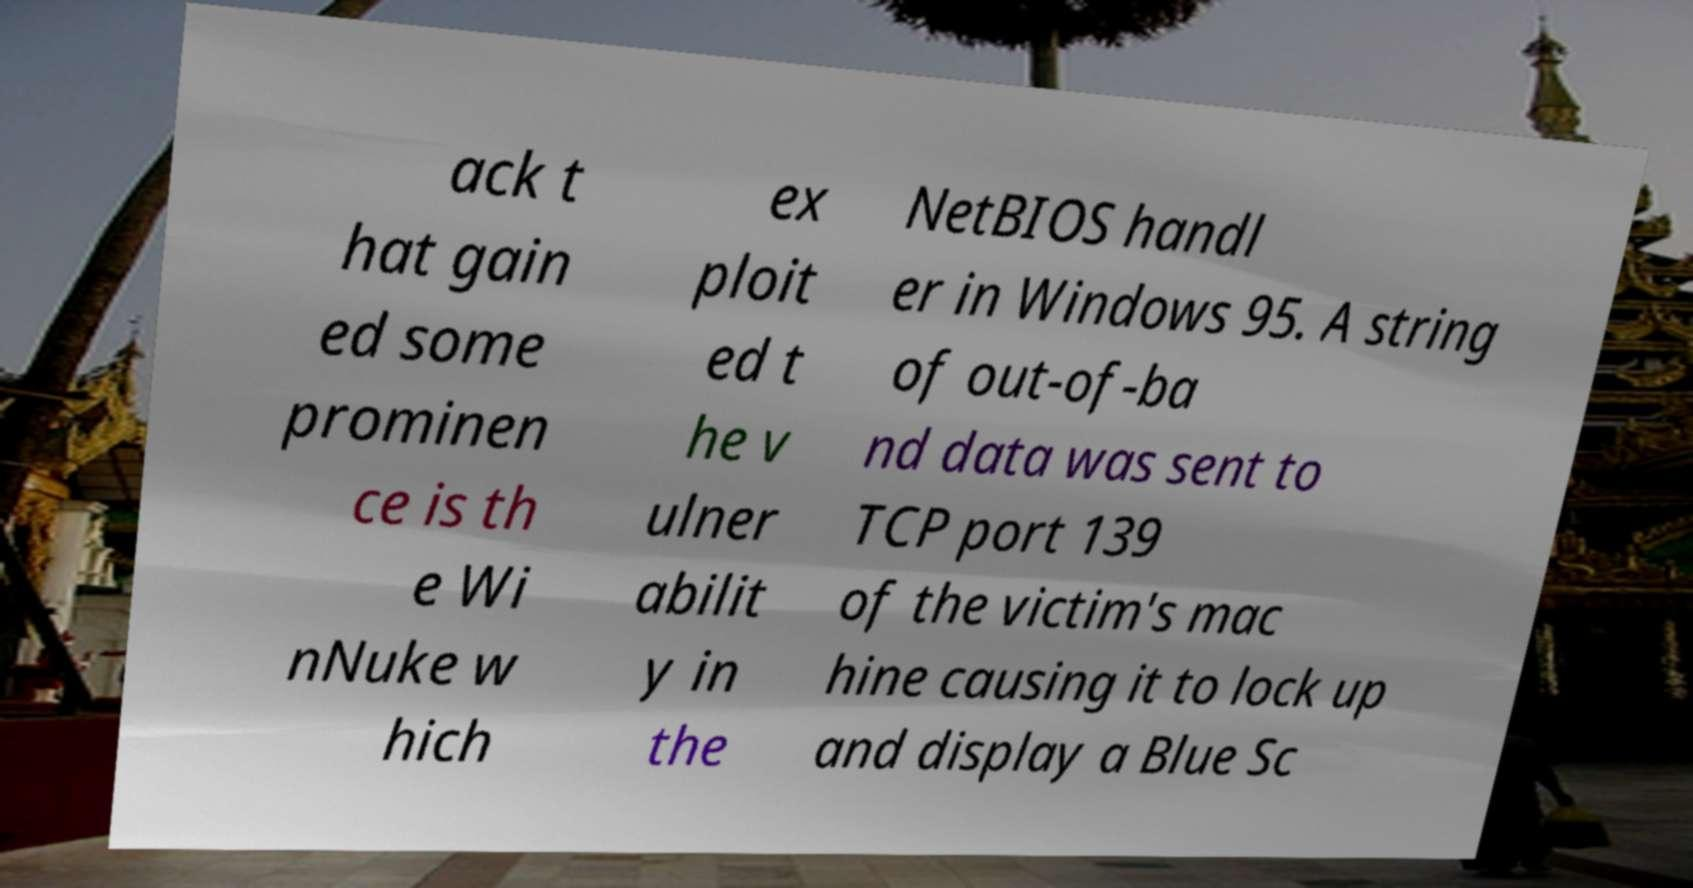Can you read and provide the text displayed in the image?This photo seems to have some interesting text. Can you extract and type it out for me? ack t hat gain ed some prominen ce is th e Wi nNuke w hich ex ploit ed t he v ulner abilit y in the NetBIOS handl er in Windows 95. A string of out-of-ba nd data was sent to TCP port 139 of the victim's mac hine causing it to lock up and display a Blue Sc 